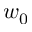<formula> <loc_0><loc_0><loc_500><loc_500>w _ { 0 }</formula> 